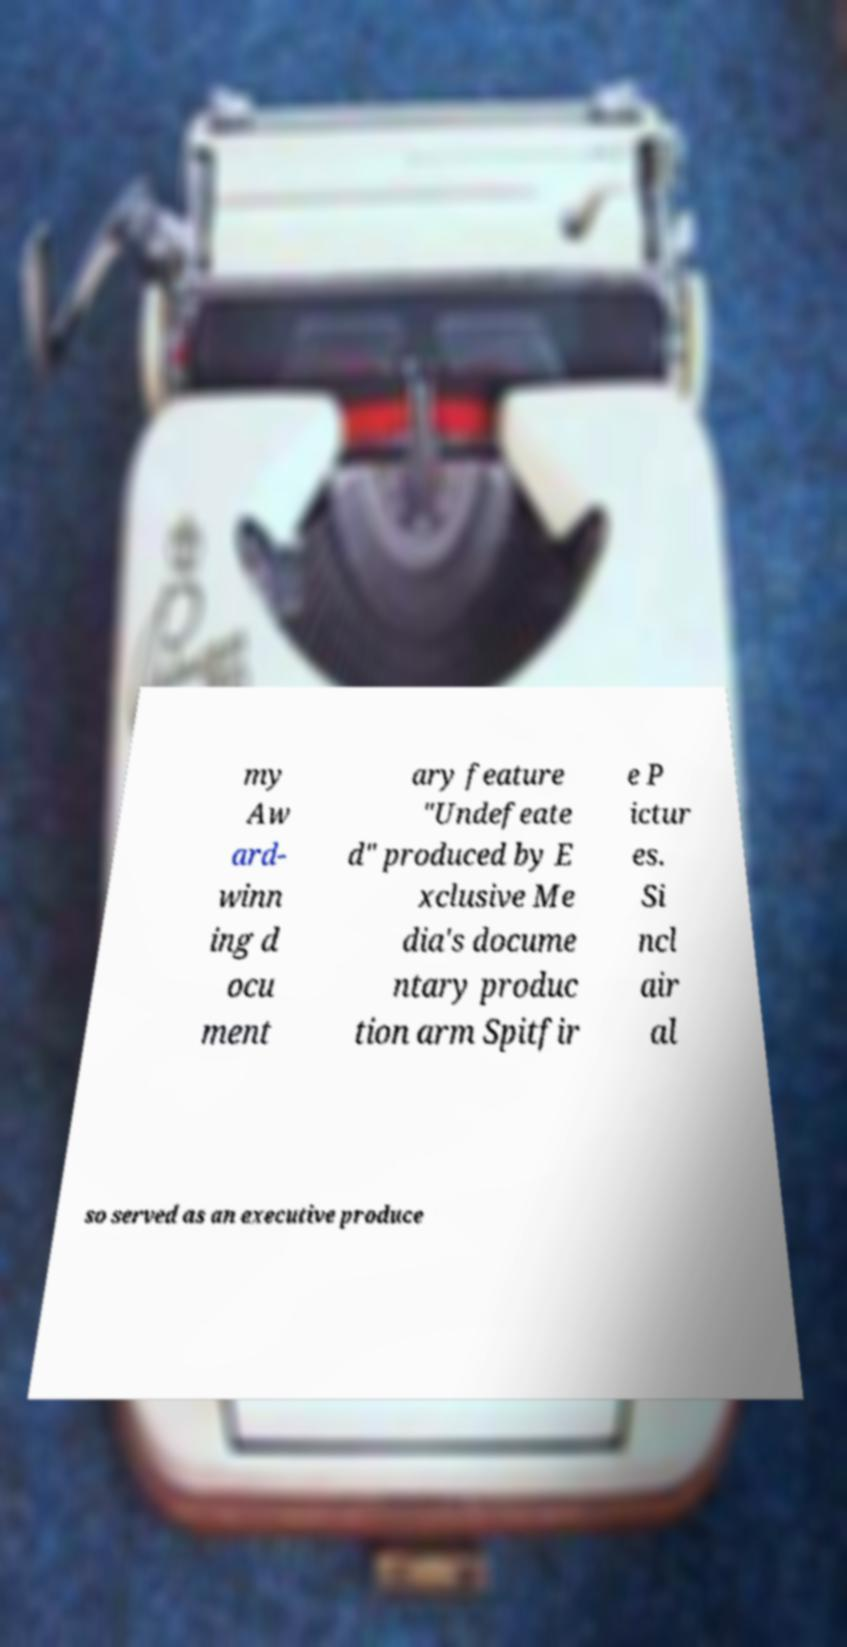I need the written content from this picture converted into text. Can you do that? my Aw ard- winn ing d ocu ment ary feature "Undefeate d" produced by E xclusive Me dia's docume ntary produc tion arm Spitfir e P ictur es. Si ncl air al so served as an executive produce 